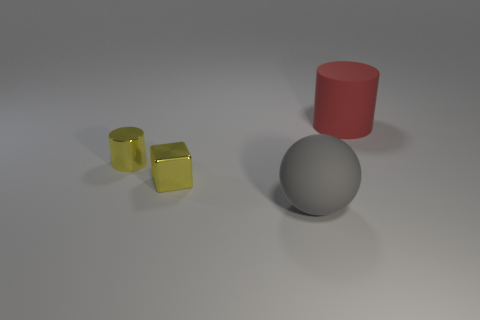What is the material of the red thing that is the same size as the ball?
Offer a terse response. Rubber. What number of large rubber objects are behind the yellow thing that is on the right side of the cylinder in front of the large red rubber cylinder?
Ensure brevity in your answer.  1. Is the color of the cylinder on the left side of the big gray sphere the same as the tiny thing in front of the yellow cylinder?
Offer a very short reply. Yes. The thing that is both behind the small block and in front of the red matte cylinder is what color?
Your response must be concise. Yellow. How many matte cylinders have the same size as the gray sphere?
Ensure brevity in your answer.  1. The tiny yellow thing right of the cylinder left of the big red cylinder is what shape?
Offer a terse response. Cube. What shape is the shiny object on the right side of the cylinder on the left side of the object that is right of the big gray sphere?
Offer a very short reply. Cube. What number of small yellow metallic objects are the same shape as the large red rubber object?
Offer a very short reply. 1. How many large red cylinders are behind the yellow metal object on the right side of the tiny yellow metallic cylinder?
Offer a terse response. 1. How many matte objects are either tiny yellow things or large balls?
Offer a very short reply. 1. 